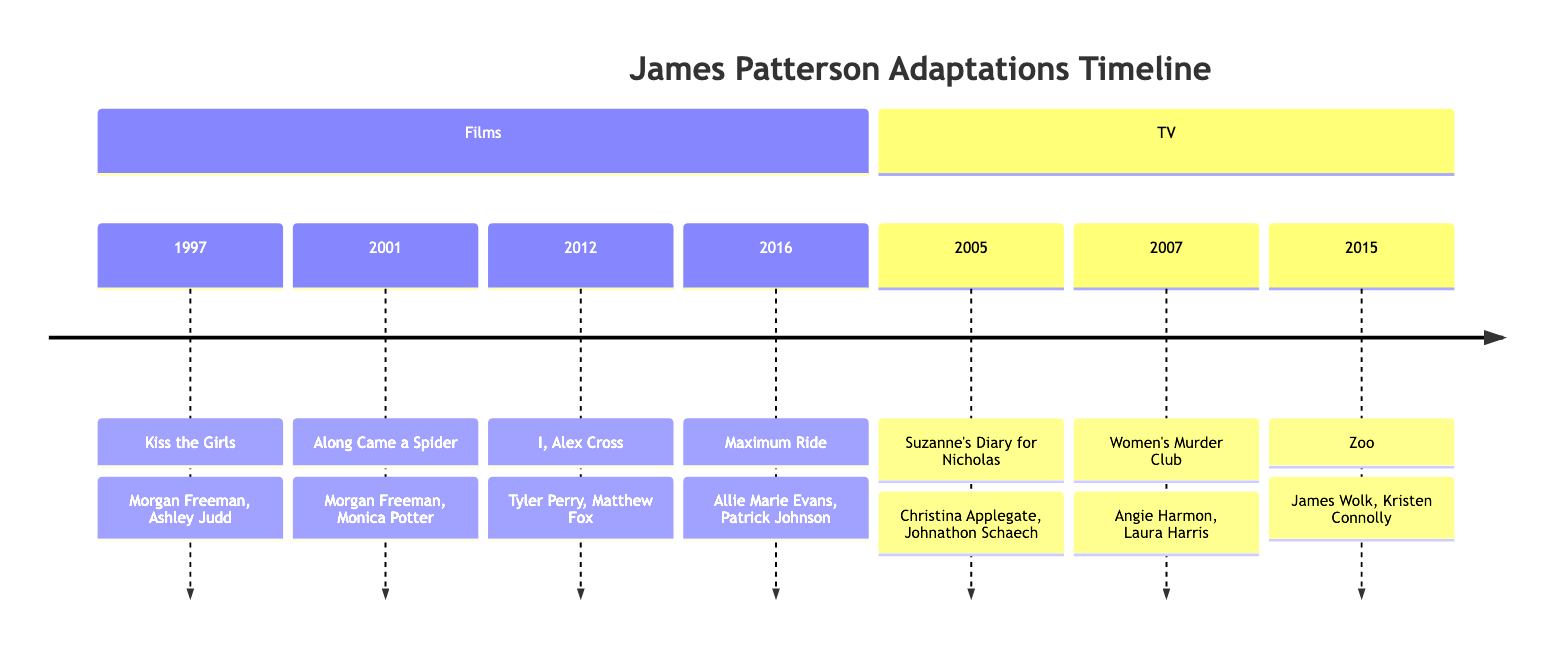What film adaptation was released in 1997? Referring to the timeline, the film listed under the year 1997 is "Kiss the Girls."
Answer: Kiss the Girls Who starred alongside Morgan Freeman in "Along Came a Spider"? By checking the node for "Along Came a Spider," we find that Monica Potter is the co-star mentioned.
Answer: Monica Potter How many TV series adaptations are listed? By observing the TV section of the timeline, there are three adaptations: "Suzanne's Diary for Nicholas," "Women's Murder Club," and "Zoo."
Answer: 3 What is the release year of "I, Alex Cross"? Looking at the timeline, "I, Alex Cross" is found under the Films section and is associated with the year 2012.
Answer: 2012 Which adaptation features Tyler Perry? The timeline shows "I, Alex Cross" under the Films section, where Tyler Perry is listed as a key cast member.
Answer: I, Alex Cross What are the key cast members of the TV series "Zoo"? Checking the details for "Zoo" in the TV section, the key cast members mentioned are James Wolk and Kristen Connolly.
Answer: James Wolk, Kristen Connolly Which film adaptation has the latest release year? By reviewing the Films section, "Maximum Ride," released in 2016, has the latest release year.
Answer: Maximum Ride What type of adaptation is "Women's Murder Club"? The timeline specifies that "Women's Murder Club" is categorized as a TV Series.
Answer: TV Series Who starred in "Kiss the Girls"? The timeline provides that Ashley Judd starred alongside Morgan Freeman in "Kiss the Girls."
Answer: Ashley Judd 